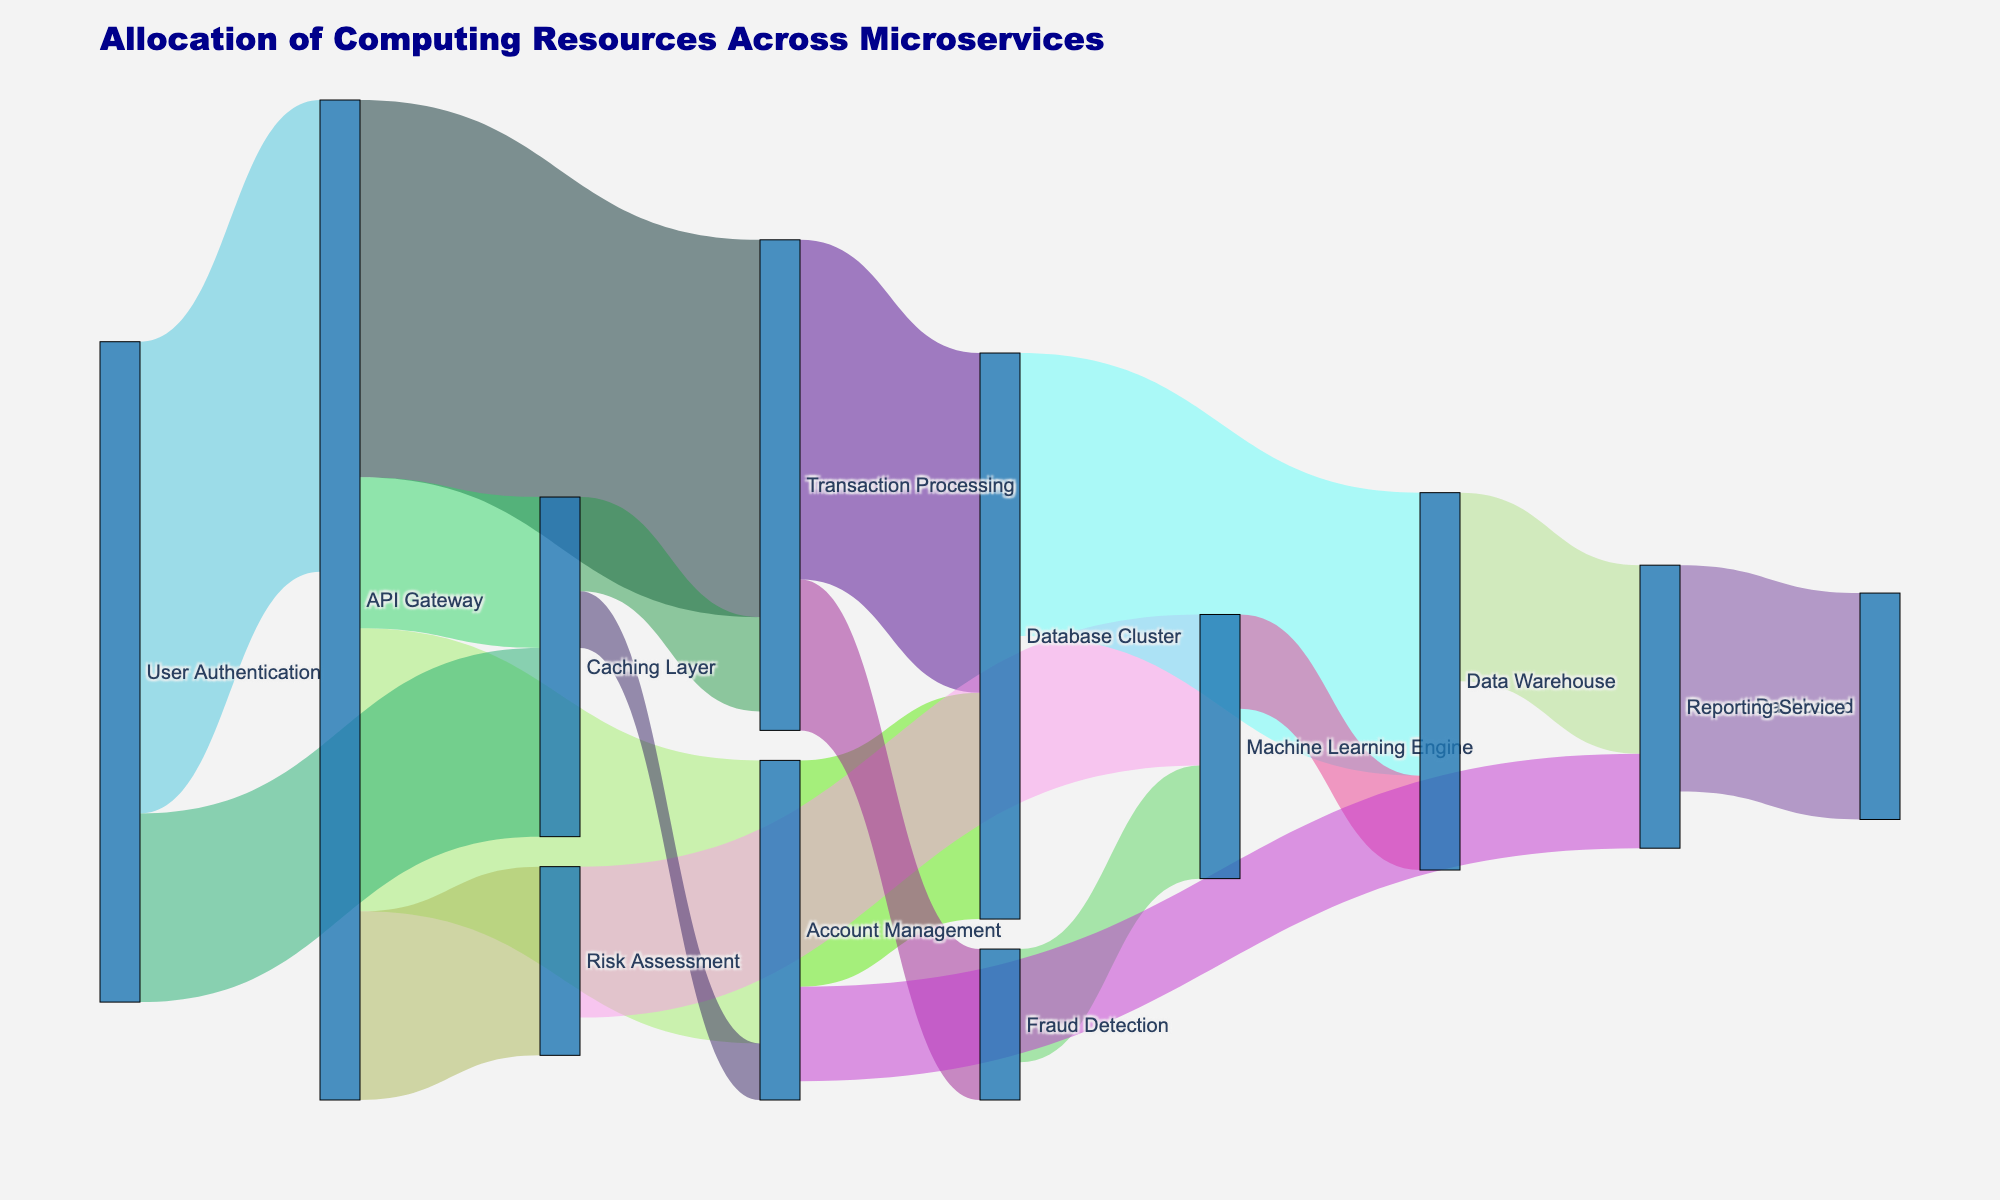What is the title of the figure? The title is usually found at the top of the figure and provides a brief description of what the figure represents. In this figure, the title is "Allocation of Computing Resources Across Microservices."
Answer: Allocation of Computing Resources Across Microservices Which microservice receives the most significant allocation from the API Gateway? Look at the links originating from the "API Gateway" node and identify which target node has the largest value. The largest value connecting from the API Gateway is 20, which leads to "Transaction Processing."
Answer: Transaction Processing How many resources are allocated to the Database Cluster from all sources? To determine the total resources received by the Database Cluster, sum the values of all incoming links to it. The incoming allocations are 18 from Transaction Processing and 12 from Account Management, making the total 18 + 12 = 30.
Answer: 30 What is the smallest allocation value shown in the diagram? To find the smallest value, review the numbers associated with each link. The smallest value is 3, allocated from the Caching Layer to Account Management.
Answer: 3 Compare the allocation from the User Authentication to the Caching Layer with the allocation from the API Gateway to the Caching Layer. Which one is larger? Compare the values of the links from User Authentication to Caching Layer (10) and from API Gateway to Caching Layer (8). The allocation from User Authentication to Caching Layer is larger.
Answer: User Authentication to Caching Layer Which microservice has the most connections to other services? Identify the node with the highest number of outgoing and incoming connections. The "API Gateway" has the most connections, connecting to Transaction Processing, Account Management, Risk Assessment, and Caching Layer.
Answer: API Gateway How many resources flow into the Machine Learning Engine? To find the total resources flowing into the Machine Learning Engine, sum the values of all incoming links. The incoming allocations are 8 from Risk Assessment and 6 from Fraud Detection, making a total of 8 + 6 = 14.
Answer: 14 What is the total resource allocation routed through the API Gateway? To determine this, sum the values of all links originating from the API Gateway. The values are 20 (Transaction Processing) + 15 (Account Management) + 10 (Risk Assessment) + 8 (Caching Layer), resulting in 20 + 15 + 10 + 8 = 53.
Answer: 53 What is the direct resource allocation to the Reporting Service? Direct allocations are from Account Management (5) and Data Warehouse (10) to the Reporting Service, resulting in a total of 5 + 10 = 15.
Answer: 15 